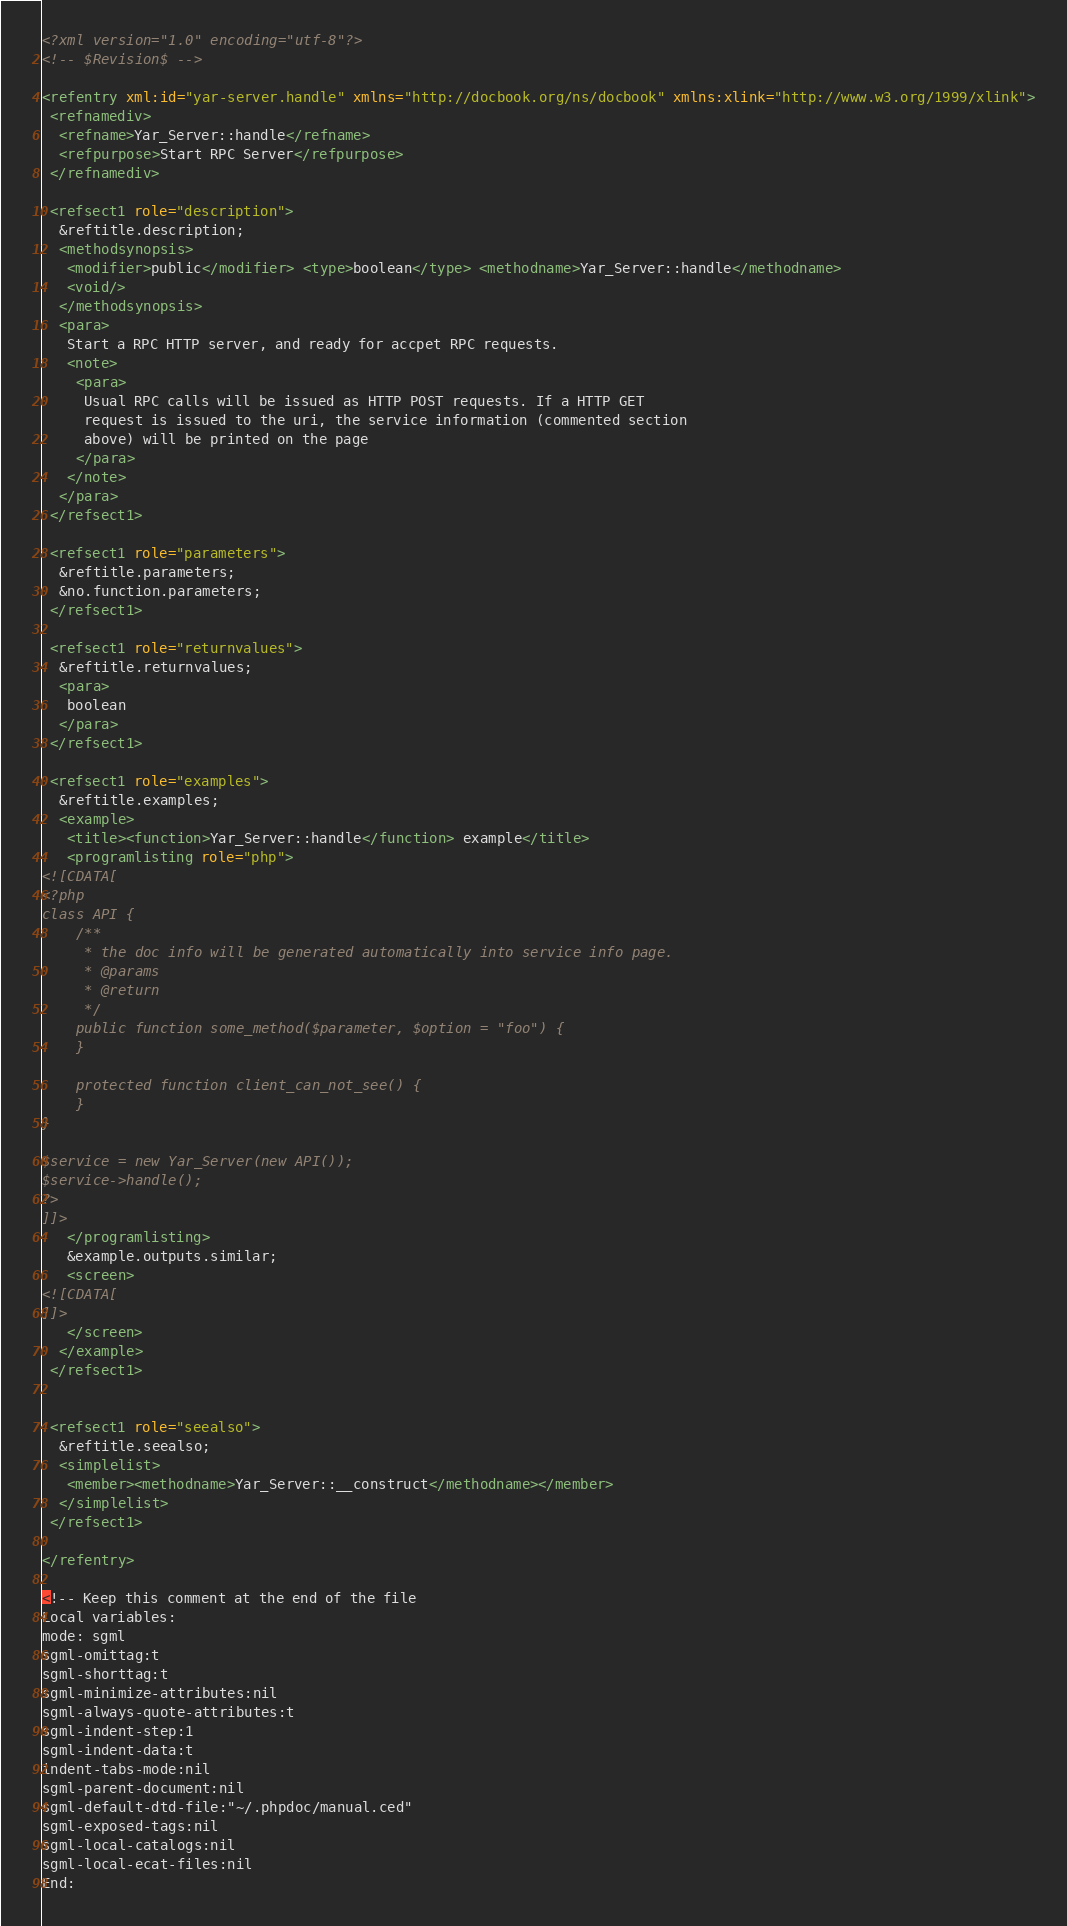Convert code to text. <code><loc_0><loc_0><loc_500><loc_500><_XML_><?xml version="1.0" encoding="utf-8"?>
<!-- $Revision$ -->

<refentry xml:id="yar-server.handle" xmlns="http://docbook.org/ns/docbook" xmlns:xlink="http://www.w3.org/1999/xlink">
 <refnamediv>
  <refname>Yar_Server::handle</refname>
  <refpurpose>Start RPC Server</refpurpose>
 </refnamediv>

 <refsect1 role="description">
  &reftitle.description;
  <methodsynopsis>
   <modifier>public</modifier> <type>boolean</type> <methodname>Yar_Server::handle</methodname>
   <void/>
  </methodsynopsis>
  <para>
   Start a RPC HTTP server, and ready for accpet RPC requests.
   <note>
    <para>
     Usual RPC calls will be issued as HTTP POST requests. If a HTTP GET
     request is issued to the uri, the service information (commented section
     above) will be printed on the page
    </para>
   </note>
  </para>
 </refsect1>

 <refsect1 role="parameters">
  &reftitle.parameters;
  &no.function.parameters;
 </refsect1>

 <refsect1 role="returnvalues">
  &reftitle.returnvalues;
  <para>
   boolean
  </para>
 </refsect1>

 <refsect1 role="examples">
  &reftitle.examples;
  <example>
   <title><function>Yar_Server::handle</function> example</title>
   <programlisting role="php">
<![CDATA[
<?php
class API {
    /**
     * the doc info will be generated automatically into service info page.
     * @params 
     * @return
     */
    public function some_method($parameter, $option = "foo") {
    }

    protected function client_can_not_see() {
    }
}

$service = new Yar_Server(new API());
$service->handle();
?>
]]>
   </programlisting>
   &example.outputs.similar;
   <screen>
<![CDATA[
]]>
   </screen>
  </example>
 </refsect1>


 <refsect1 role="seealso">
  &reftitle.seealso;
  <simplelist>
   <member><methodname>Yar_Server::__construct</methodname></member>
  </simplelist>
 </refsect1>

</refentry>

<!-- Keep this comment at the end of the file
Local variables:
mode: sgml
sgml-omittag:t
sgml-shorttag:t
sgml-minimize-attributes:nil
sgml-always-quote-attributes:t
sgml-indent-step:1
sgml-indent-data:t
indent-tabs-mode:nil
sgml-parent-document:nil
sgml-default-dtd-file:"~/.phpdoc/manual.ced"
sgml-exposed-tags:nil
sgml-local-catalogs:nil
sgml-local-ecat-files:nil
End:</code> 